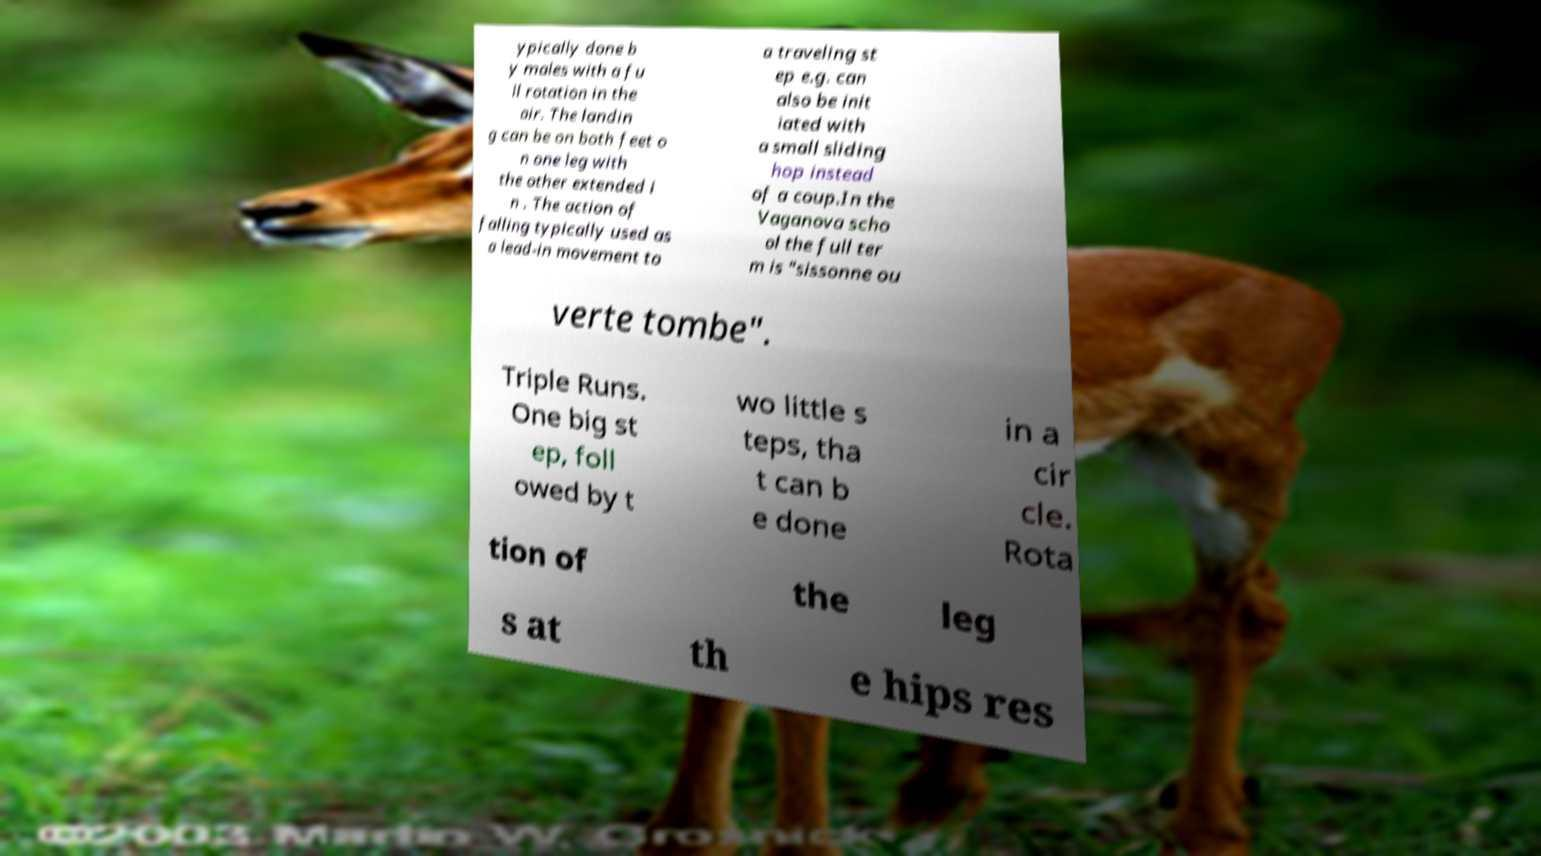Please identify and transcribe the text found in this image. ypically done b y males with a fu ll rotation in the air. The landin g can be on both feet o n one leg with the other extended i n . The action of falling typically used as a lead-in movement to a traveling st ep e.g. can also be init iated with a small sliding hop instead of a coup.In the Vaganova scho ol the full ter m is "sissonne ou verte tombe". Triple Runs. One big st ep, foll owed by t wo little s teps, tha t can b e done in a cir cle. Rota tion of the leg s at th e hips res 